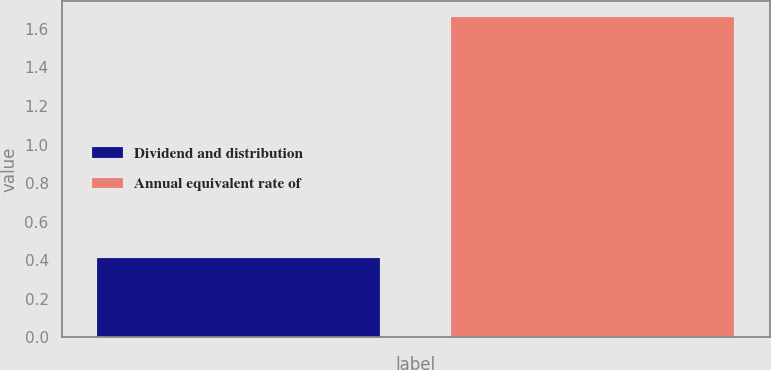Convert chart to OTSL. <chart><loc_0><loc_0><loc_500><loc_500><bar_chart><fcel>Dividend and distribution<fcel>Annual equivalent rate of<nl><fcel>0.41<fcel>1.66<nl></chart> 